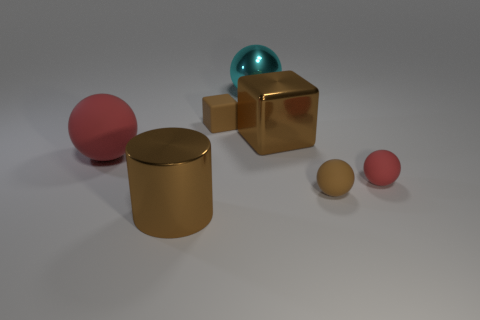Are there an equal number of cyan metallic balls in front of the cyan thing and brown shiny cylinders in front of the large brown metallic cylinder?
Offer a terse response. Yes. How many other objects are the same size as the shiny ball?
Provide a short and direct response. 3. How big is the cyan thing?
Offer a terse response. Large. Do the large red sphere and the cube to the left of the brown metal cube have the same material?
Offer a very short reply. Yes. Are there any small red matte things that have the same shape as the big cyan object?
Offer a very short reply. Yes. There is a cyan thing that is the same size as the brown cylinder; what is it made of?
Your response must be concise. Metal. There is a brown metallic cube in front of the large cyan thing; how big is it?
Offer a very short reply. Large. There is a red rubber thing on the right side of the tiny block; is it the same size as the ball that is left of the big brown metallic cylinder?
Offer a very short reply. No. What number of brown spheres are made of the same material as the brown cylinder?
Keep it short and to the point. 0. What color is the shiny cube?
Your answer should be very brief. Brown. 